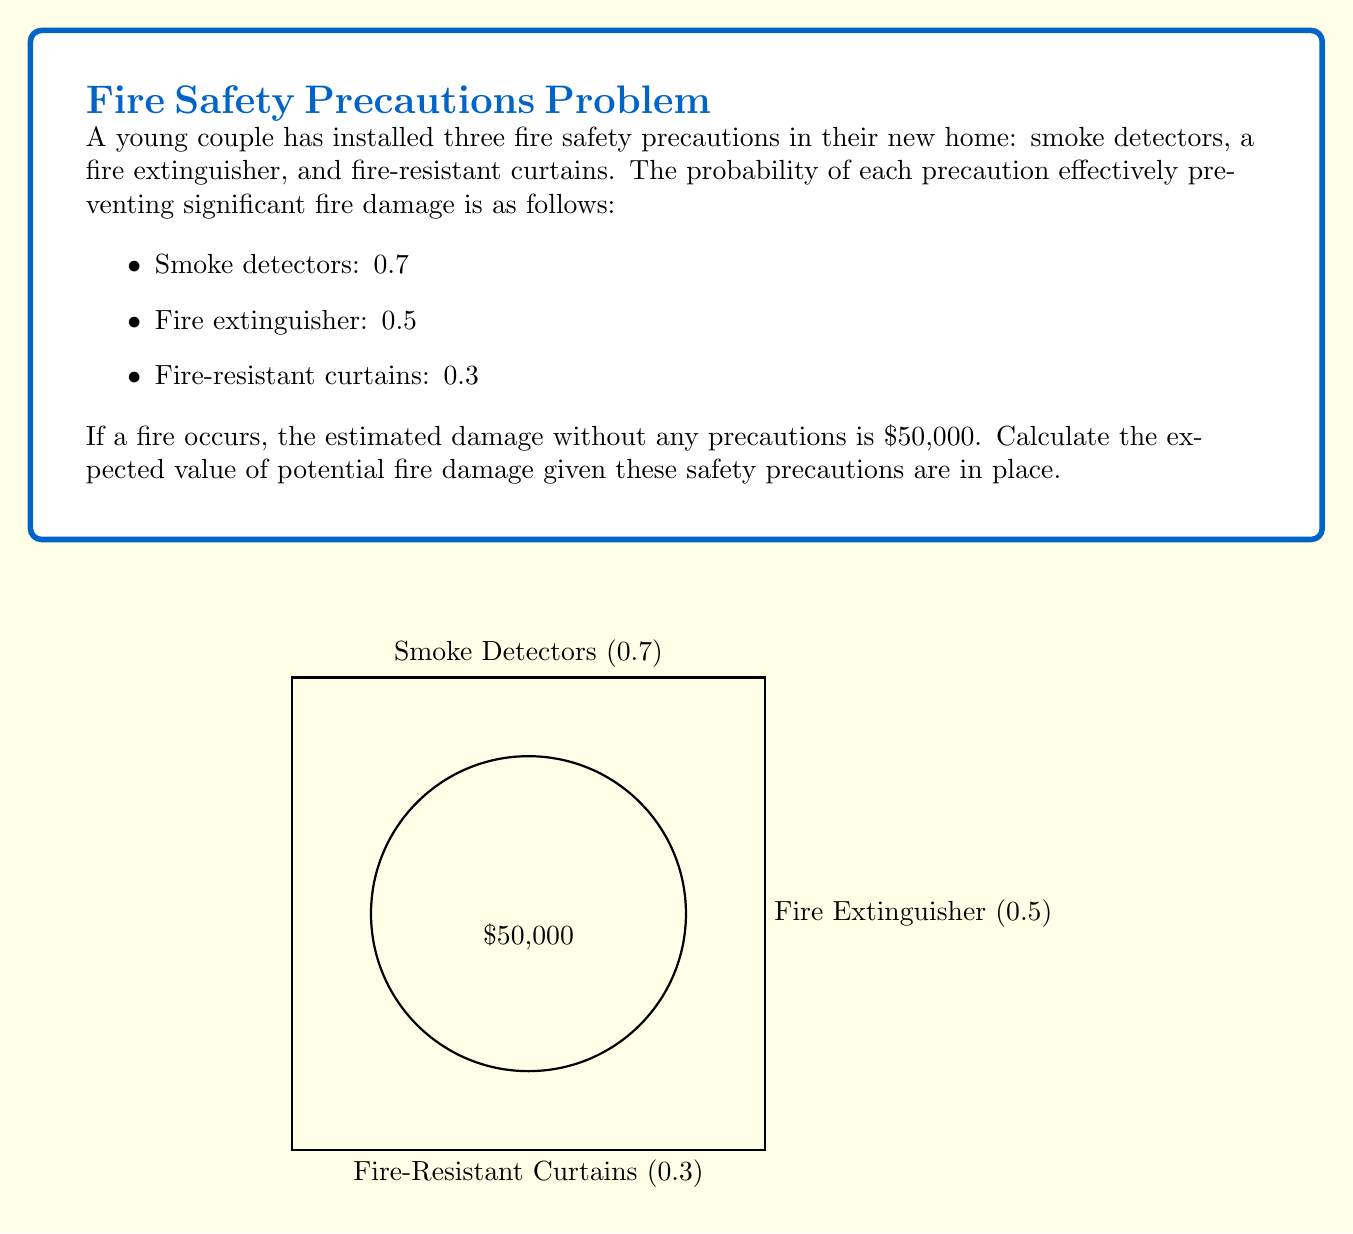Provide a solution to this math problem. Let's approach this step-by-step using the concept of expected value and the complement rule of probability.

1) First, we need to calculate the probability that all precautions fail. This is the complement of at least one precaution working:

   $P(\text{all fail}) = (1-0.7)(1-0.5)(1-0.3) = 0.3 \times 0.5 \times 0.7 = 0.105$

2) Now, the probability that at least one precaution works is:

   $P(\text{at least one works}) = 1 - P(\text{all fail}) = 1 - 0.105 = 0.895$

3) The expected value is calculated by multiplying each possible outcome by its probability and summing these products. In this case, we have two possible outcomes:

   a) All precautions fail (probability 0.105): Full damage of $50,000
   b) At least one precaution works (probability 0.895): No significant damage ($0)

4) Let's calculate the expected value:

   $E(\text{damage}) = 50000 \times 0.105 + 0 \times 0.895$

5) Simplifying:

   $E(\text{damage}) = 5250 + 0 = 5250$

Therefore, the expected value of potential fire damage, given these safety precautions, is $5,250.
Answer: $5,250 